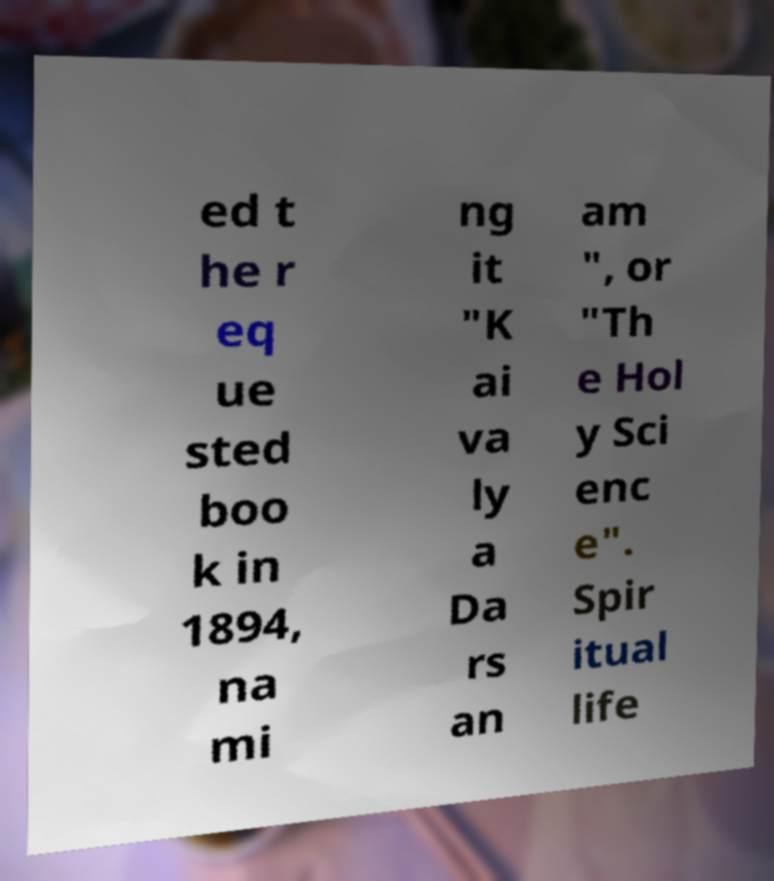There's text embedded in this image that I need extracted. Can you transcribe it verbatim? ed t he r eq ue sted boo k in 1894, na mi ng it "K ai va ly a Da rs an am ", or "Th e Hol y Sci enc e". Spir itual life 